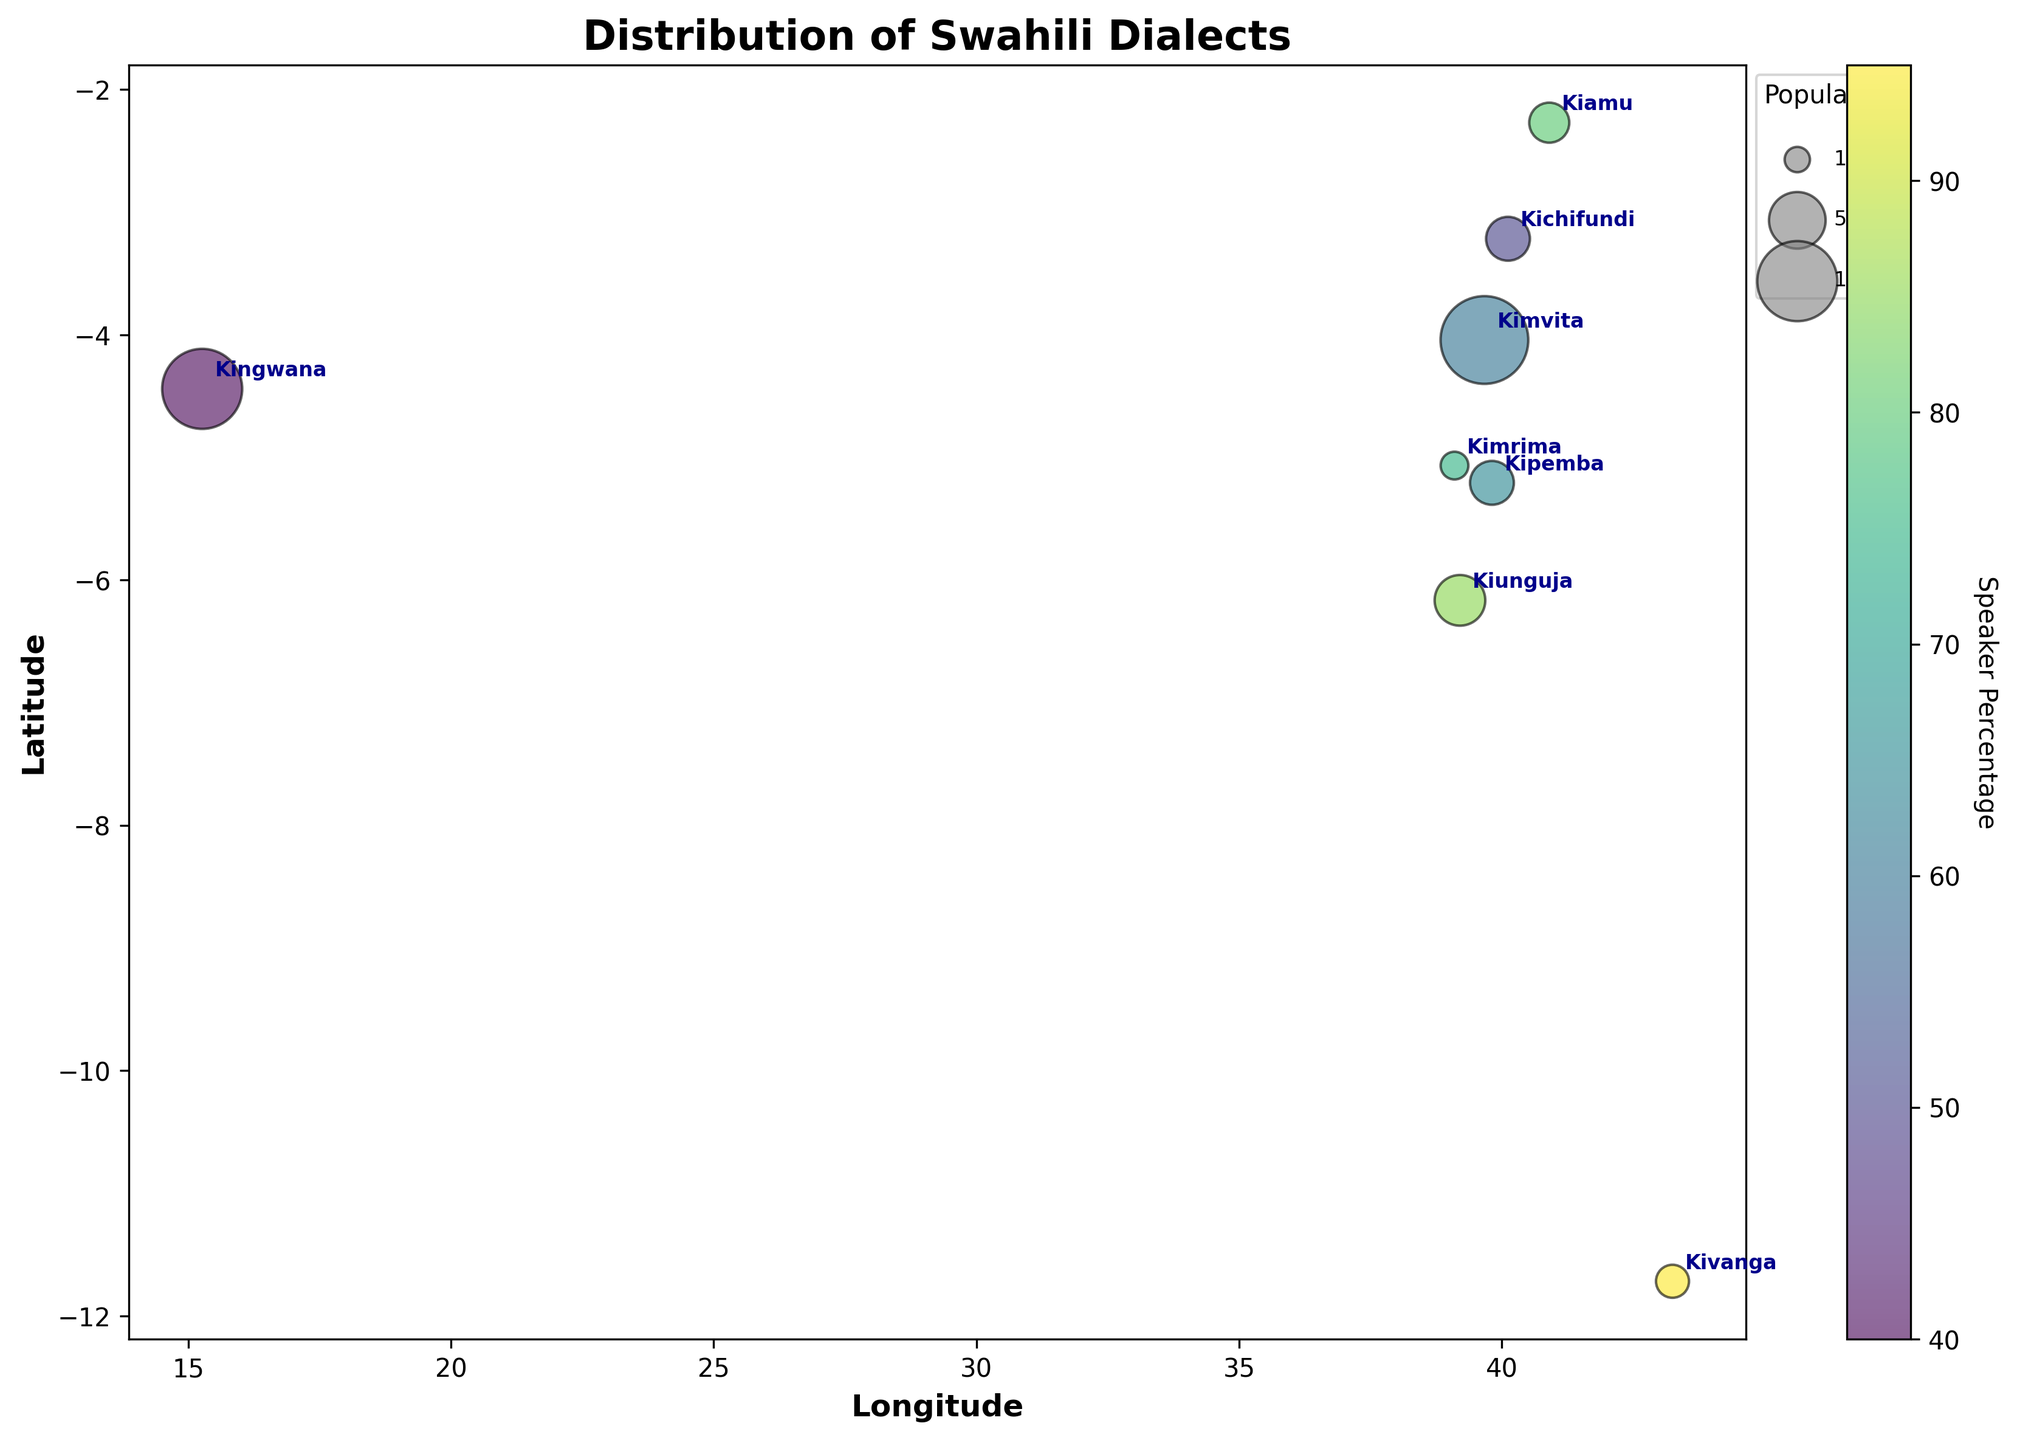What is the title of the figure? The title is displayed at the top of the figure, specifying what the figure is about.
Answer: Distribution of Swahili Dialects How many different dialects are shown in the figure? Count the number of unique points labeled with different dialect names on the figure.
Answer: 8 Which dialect has the highest speaker percentage? To identify this, look for the bubble with the highest color intensity that indicates the highest value in the color bar.
Answer: Kivanga Where is the dialect Kiamu located geographically? Refer to the labels and pinpoint the corresponding latitude and longitude on the map coordinates.
Answer: Lamu (-2.2717, 40.902) Which dialect's bubble is the largest in size? Observe the size of the bubbles and identify the one with the largest area, indicating the largest population.
Answer: Kimvita How does the population of Kiunguja compare to Kipemba? Compare the size of the bubbles representing Kiunguja and Kipemba. The larger bubble indicates a higher population.
Answer: Kiunguja has a larger population than Kipemba Calculate the average latitude of all the dialects shown. Sum all the latitude values and divide by the number of dialects. Perform the calculation: (-6.1659 - 4.0435 - 2.2717 - 5.0674 - 5.2080 - 3.2182 - 4.4419 - 11.7172) / 8 = -5.5167
Answer: -5.5167 Which dialects have a speaker percentage greater than 70%? Check the color intensity for values greater than 70% and list the corresponding bubbles.
Answer: Kiunguja, Kiamu, Kimrima, Kivanga Order the dialects by their longitude from west to east. Arrange the dialects based on their longitude values from the smallest to the largest.
Answer: Kingwana, Kiunguja, Kimrima, Kipemba, Kimvita, Kichifundi, Kiamu, Kivanga What is the variation in population size among the dialects? Find the difference between the largest and smallest populations by identifying the largest and smallest bubbles. The largest bubble represents Kimvita (1200) and the smallest represents Kimrima (120). 1200 - 120 = 1080
Answer: 1080 